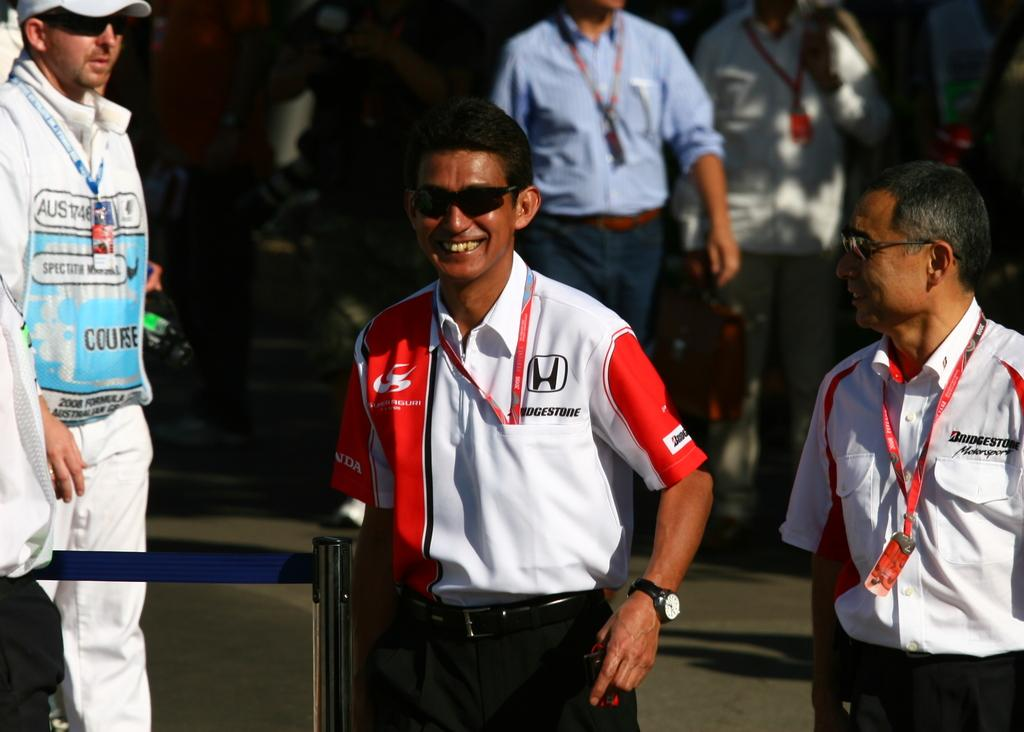<image>
Write a terse but informative summary of the picture. A group of men are standing with two of them having Bridgestone on their shirts. 